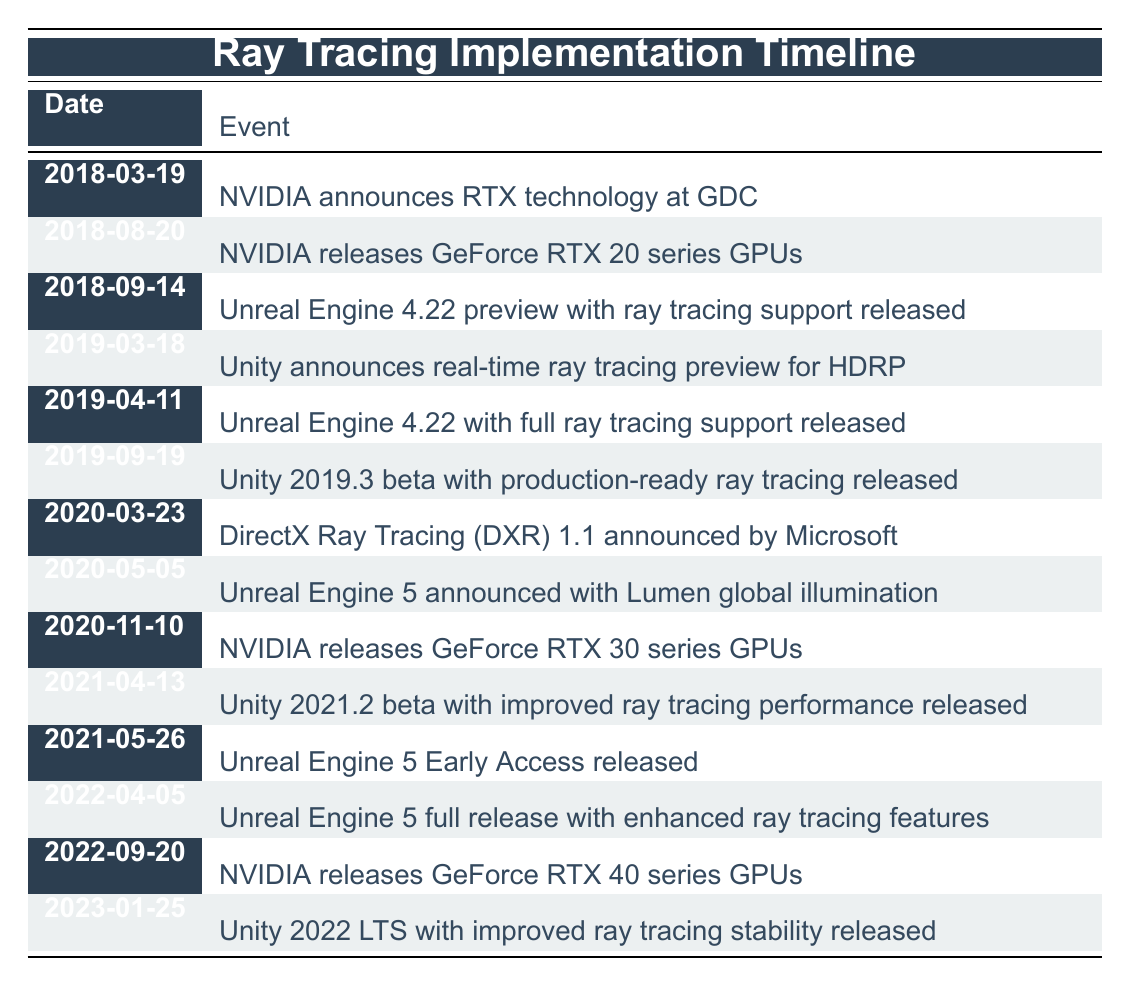What date did NVIDIA announce RTX technology? The table shows that NVIDIA announced RTX technology on 2018-03-19.
Answer: 2018-03-19 What event occurred on 2020-05-05? According to the table, on 2020-05-05, Unreal Engine 5 was announced with Lumen global illumination.
Answer: Unreal Engine 5 announced with Lumen global illumination Which engine had ray tracing support released first, Unreal Engine or Unity? From the table, Unreal Engine 4.22 preview with ray tracing support was released on 2018-09-14, and Unity announced real-time ray tracing preview for HDRP on 2019-03-18. Therefore, Unreal Engine had ray tracing support released first.
Answer: Unreal Engine How many times did NVIDIA release new GPUs in the timeline? By examining the table, NVIDIA released GPUs on two occasions: first on 2018-08-20 (GeForce RTX 20 series) and again on 2020-11-10 (GeForce RTX 30 series), and on 2022-09-20 (GeForce RTX 40 series), so that's three total releases.
Answer: 3 Was there an announcement for DirectX Ray Tracing before or after Unreal Engine 5 was announced? The table indicates that DirectX Ray Tracing (DXR) 1.1 was announced on 2020-03-23 and Unreal Engine 5 was announced on 2020-05-05. Therefore, the announcement for DirectX Ray Tracing occurred before Unreal Engine 5 was announced.
Answer: Before How much time passed between the announcement of NVIDIA's GeForce RTX 20 series GPUs and the full ray tracing support release in Unreal Engine? The GeForce RTX 20 series GPUs were released on 2018-08-20, and the full ray tracing support in Unreal Engine 4.22 was released on 2019-04-11. The time between the two dates can be calculated by subtracting the earlier date from the later: 2019-04-11 - 2018-08-20 is roughly 7 months and 21 days.
Answer: Approximately 7 months and 21 days Did Unity 2021.2 enhance ray tracing performance? Yes, the table shows that Unity 2021.2 beta with improved ray tracing performance was released on 2021-04-13, which validates the statement.
Answer: Yes Which engine was associated with the earliest event in the timeline? The earliest event in the timeline was on 2018-03-19 when NVIDIA announced RTX technology. This event is associated with NVIDIA, not an engine; however, the first engine to show involvement with ray tracing came shortly after. The first mention of an engine is Unreal Engine 4.22 preview on 2018-09-14, so it indirectly starts a trend.
Answer: NVIDIA and Unreal Engine 